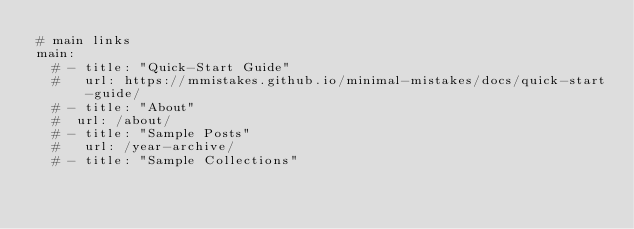Convert code to text. <code><loc_0><loc_0><loc_500><loc_500><_YAML_># main links
main:
  # - title: "Quick-Start Guide"
  #   url: https://mmistakes.github.io/minimal-mistakes/docs/quick-start-guide/
  # - title: "About"
  #  url: /about/
  # - title: "Sample Posts"
  #   url: /year-archive/
  # - title: "Sample Collections"</code> 